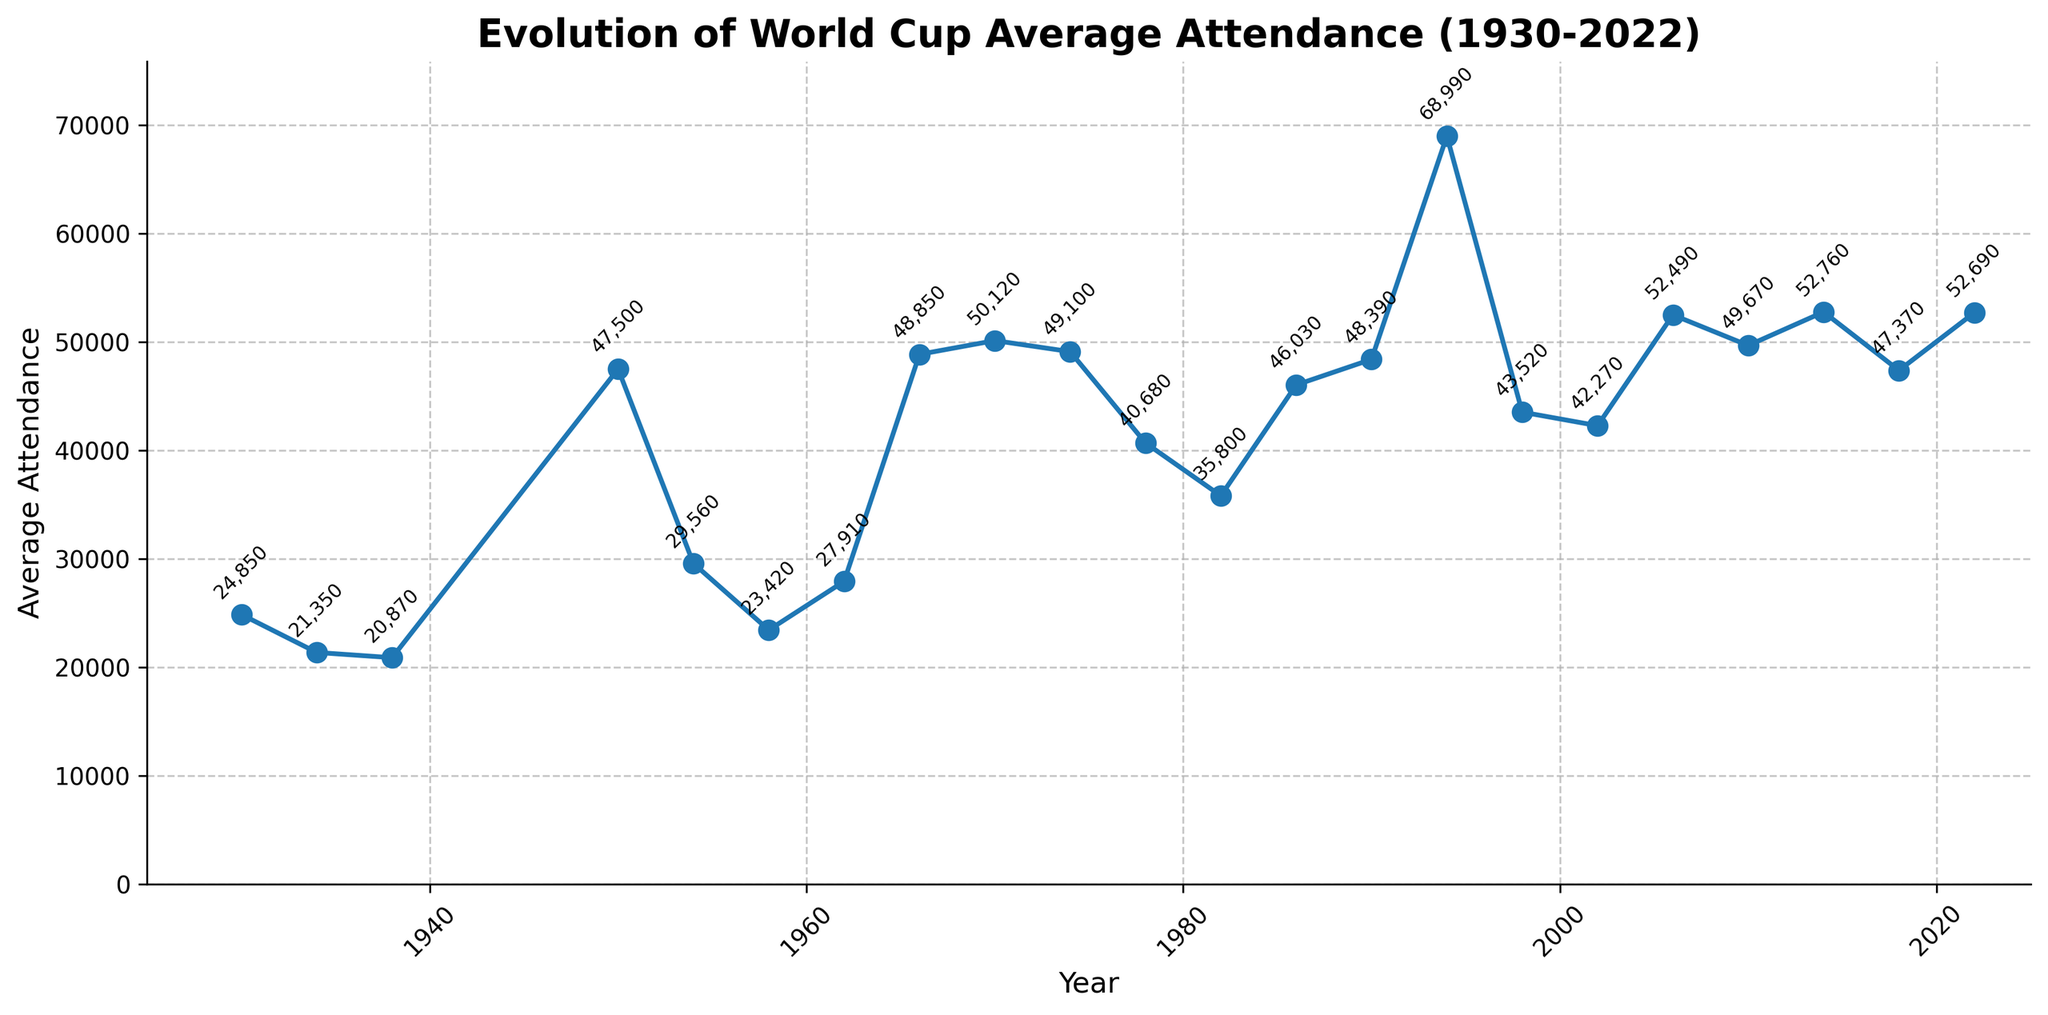What's the highest average attendance recorded for a World Cup? The highest average attendance recorded is marked by the peak point on the plot. In 1994, the attendance was 68,990.
Answer: 68,990 What was the average attendance like in the first three World Cups (1930, 1934, 1938)? The average attendance for 1930 was 24,850, for 1934 it was 21,350, and for 1938 it was 20,870.
Answer: 24,850; 21,350; 20,870 Which World Cup had a higher average attendance, 1970 or 2006? By comparing the heights of the two points, the attendance in 1970 was 50,120, and in 2006 it was 52,490. Therefore, 2006 had a higher average attendance.
Answer: 2006 How much did the average attendance increase from 1938 to 1950? Subtract the average attendance of 1938 (20,870) from 1950 (47,500) to get the difference: 47,500 - 20,870 = 26,630.
Answer: 26,630 What is the trend between 1994 and 2022 in terms of average attendance? Observing the plot, the attendance peaked in 1994 and then dropped in 1998, followed by some fluctuations, it rose again to a similar peak in 2006, almost matching in 2014 and 2022.
Answer: Fluctuating with two high peaks In which years was the average attendance nearly equal? By looking at the annotations, the closest average attendances were in 1966 (48,850) and 1970 (50,120), and 1990 (48,390) and 2010 (49,670).
Answer: 1966 and 1970; 1990 and 2010 Which World Cup experienced the largest drop in average attendance compared to the previous tournament? Calculating the differences between each tournament's attendance, the largest drop was from 1994 (68,990) to 1998 (43,520), with a decrease of 25,470.
Answer: 1998 How does the average attendance in 1930 compare to the average attendance in 2022? The average attendance in 1930 was 24,850, while in 2022 it was 52,690. 2022 had a significantly higher attendance.
Answer: 2022 had a higher attendance What was the average attendance difference between the two peaks in 1994 and 2014? The average attendance in 1994 was 68,990, and in 2014 it was 52,760. The difference is 68,990 - 52,760 = 16,230.
Answer: 16,230 